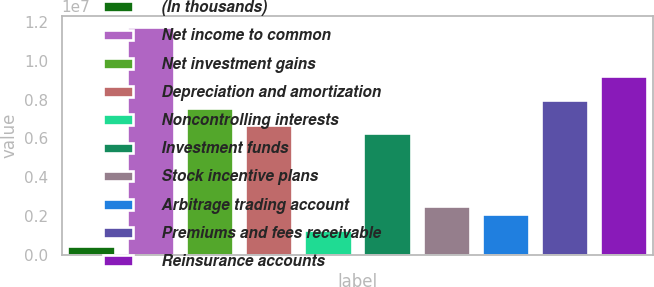Convert chart to OTSL. <chart><loc_0><loc_0><loc_500><loc_500><bar_chart><fcel>(In thousands)<fcel>Net income to common<fcel>Net investment gains<fcel>Depreciation and amortization<fcel>Noncontrolling interests<fcel>Investment funds<fcel>Stock incentive plans<fcel>Arbitrage trading account<fcel>Premiums and fees receivable<fcel>Reinsurance accounts<nl><fcel>419861<fcel>1.17547e+07<fcel>7.5566e+06<fcel>6.71698e+06<fcel>1.25948e+06<fcel>6.29718e+06<fcel>2.5189e+06<fcel>2.09909e+06<fcel>7.97641e+06<fcel>9.23583e+06<nl></chart> 